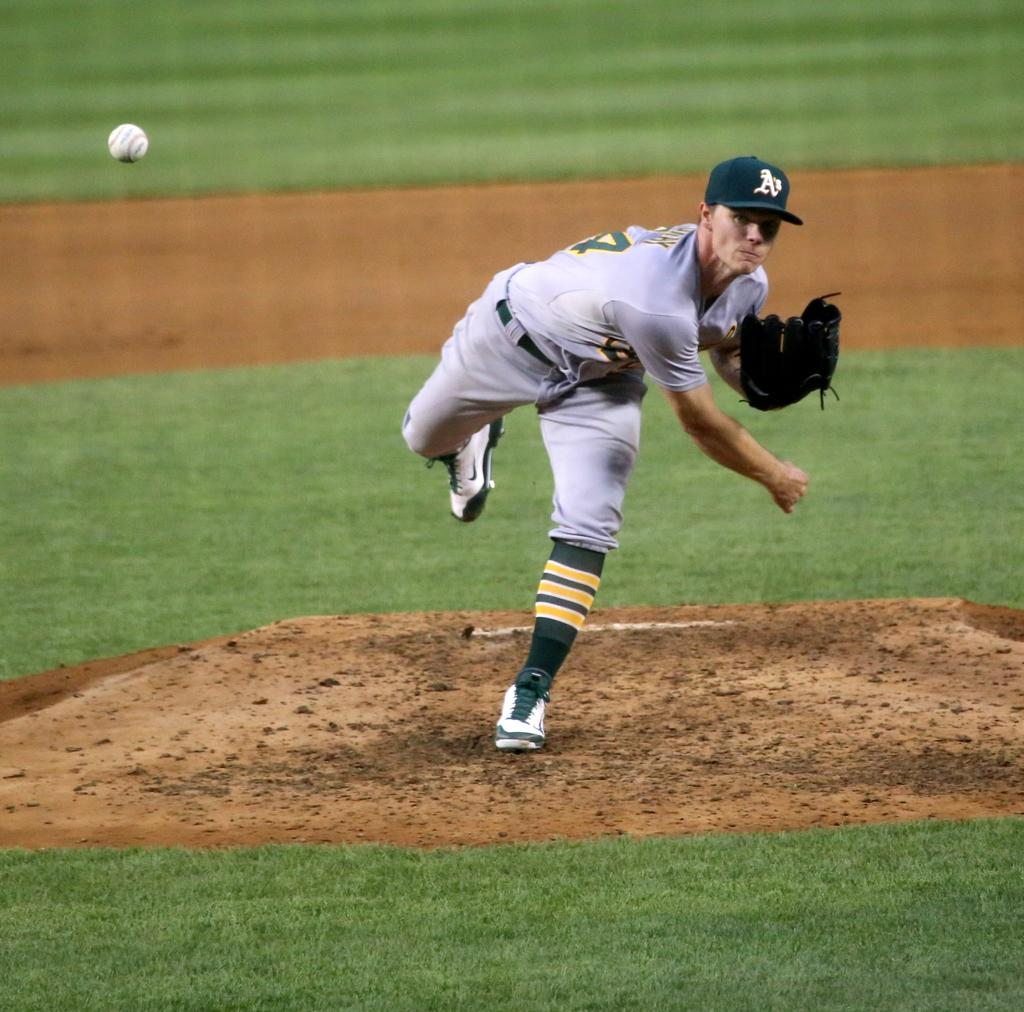Provide a one-sentence caption for the provided image. a man with an A's hat om his head on the mound. 